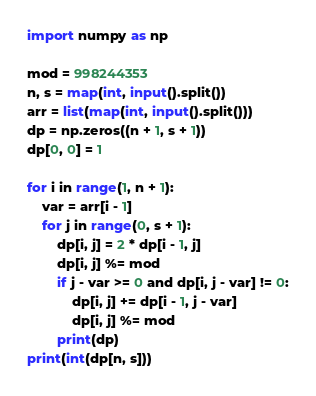Convert code to text. <code><loc_0><loc_0><loc_500><loc_500><_Python_>import numpy as np

mod = 998244353
n, s = map(int, input().split())
arr = list(map(int, input().split()))
dp = np.zeros((n + 1, s + 1))
dp[0, 0] = 1

for i in range(1, n + 1):
    var = arr[i - 1]
    for j in range(0, s + 1):
        dp[i, j] = 2 * dp[i - 1, j]
        dp[i, j] %= mod
        if j - var >= 0 and dp[i, j - var] != 0:
            dp[i, j] += dp[i - 1, j - var]
            dp[i, j] %= mod
        print(dp)
print(int(dp[n, s]))</code> 